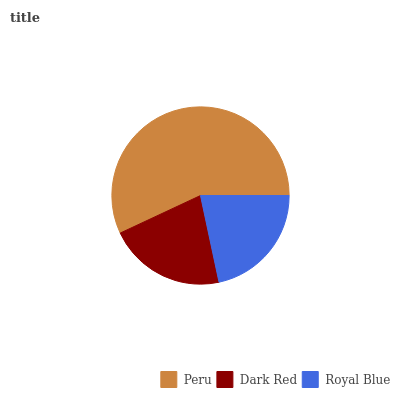Is Dark Red the minimum?
Answer yes or no. Yes. Is Peru the maximum?
Answer yes or no. Yes. Is Royal Blue the minimum?
Answer yes or no. No. Is Royal Blue the maximum?
Answer yes or no. No. Is Royal Blue greater than Dark Red?
Answer yes or no. Yes. Is Dark Red less than Royal Blue?
Answer yes or no. Yes. Is Dark Red greater than Royal Blue?
Answer yes or no. No. Is Royal Blue less than Dark Red?
Answer yes or no. No. Is Royal Blue the high median?
Answer yes or no. Yes. Is Royal Blue the low median?
Answer yes or no. Yes. Is Peru the high median?
Answer yes or no. No. Is Dark Red the low median?
Answer yes or no. No. 